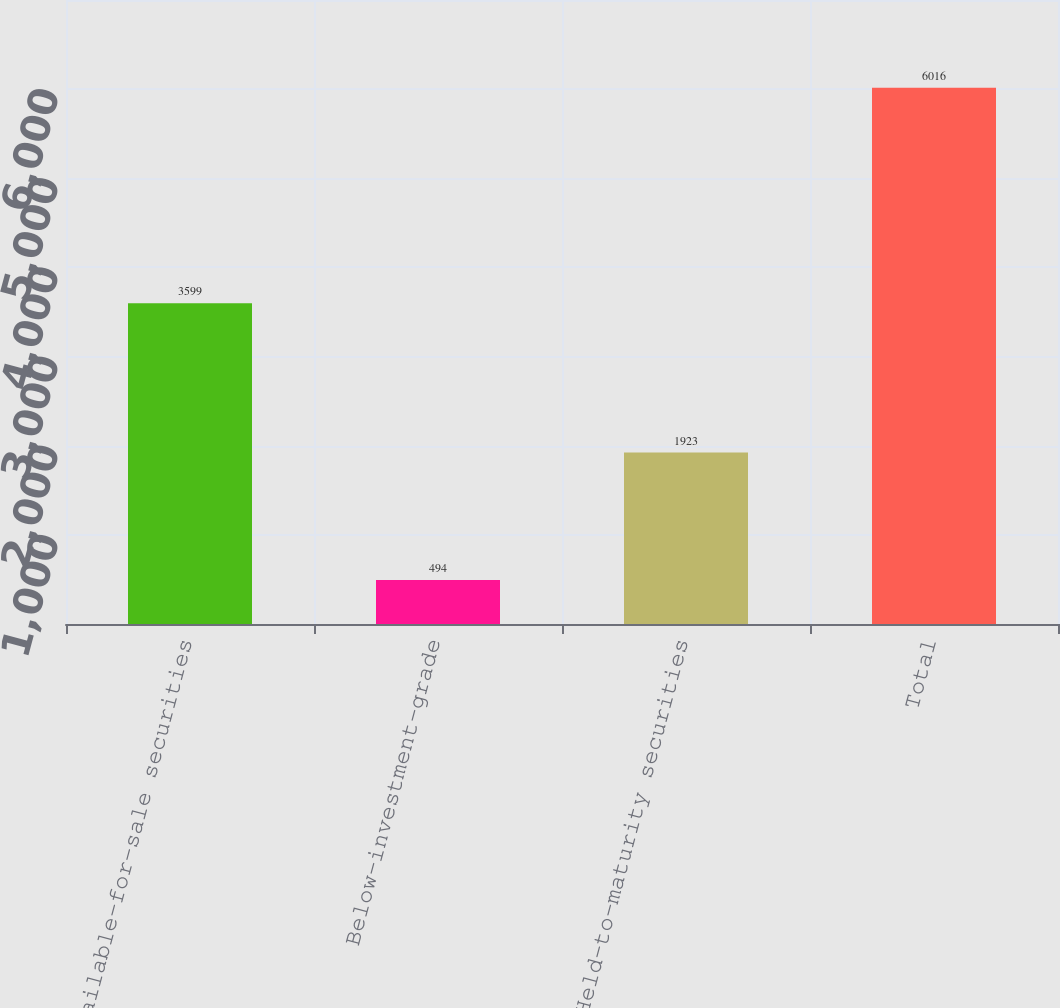<chart> <loc_0><loc_0><loc_500><loc_500><bar_chart><fcel>Available-for-sale securities<fcel>Below-investment-grade<fcel>Held-to-maturity securities<fcel>Total<nl><fcel>3599<fcel>494<fcel>1923<fcel>6016<nl></chart> 